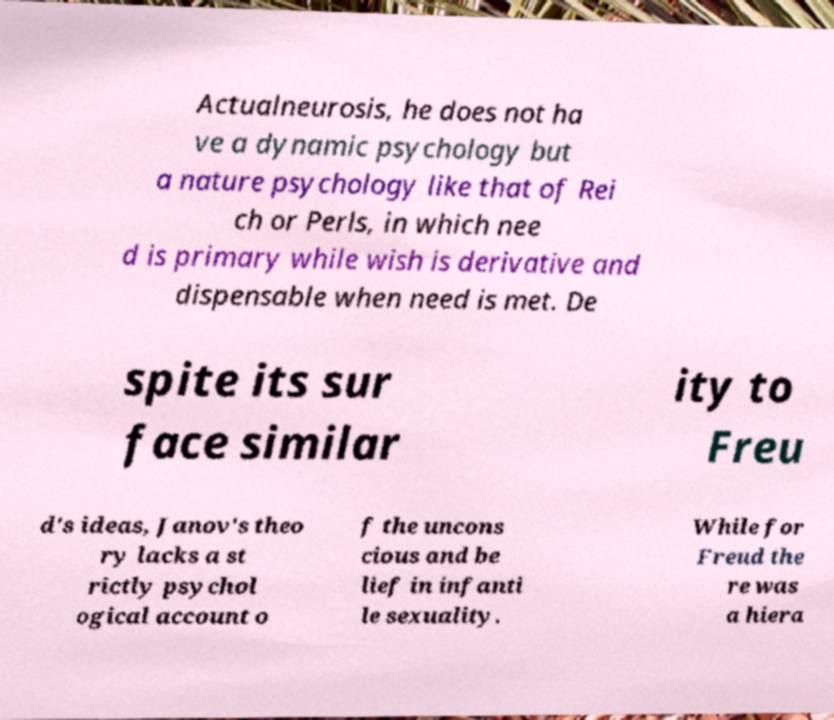What messages or text are displayed in this image? I need them in a readable, typed format. Actualneurosis, he does not ha ve a dynamic psychology but a nature psychology like that of Rei ch or Perls, in which nee d is primary while wish is derivative and dispensable when need is met. De spite its sur face similar ity to Freu d's ideas, Janov's theo ry lacks a st rictly psychol ogical account o f the uncons cious and be lief in infanti le sexuality. While for Freud the re was a hiera 